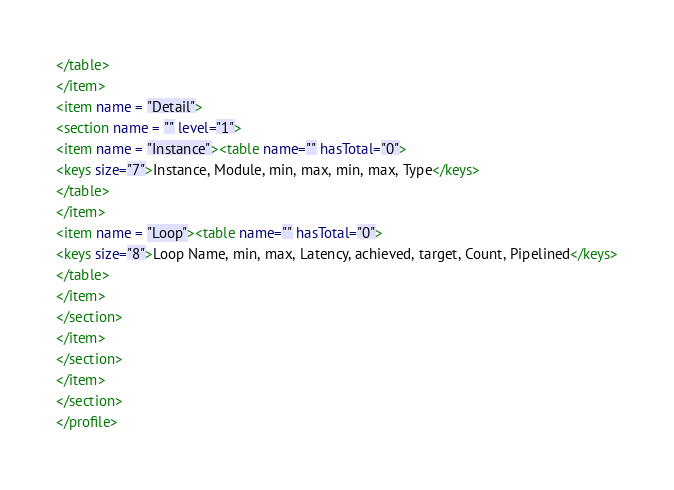Convert code to text. <code><loc_0><loc_0><loc_500><loc_500><_XML_></table>
</item>
<item name = "Detail">
<section name = "" level="1">
<item name = "Instance"><table name="" hasTotal="0">
<keys size="7">Instance, Module, min, max, min, max, Type</keys>
</table>
</item>
<item name = "Loop"><table name="" hasTotal="0">
<keys size="8">Loop Name, min, max, Latency, achieved, target, Count, Pipelined</keys>
</table>
</item>
</section>
</item>
</section>
</item>
</section>
</profile>
</code> 